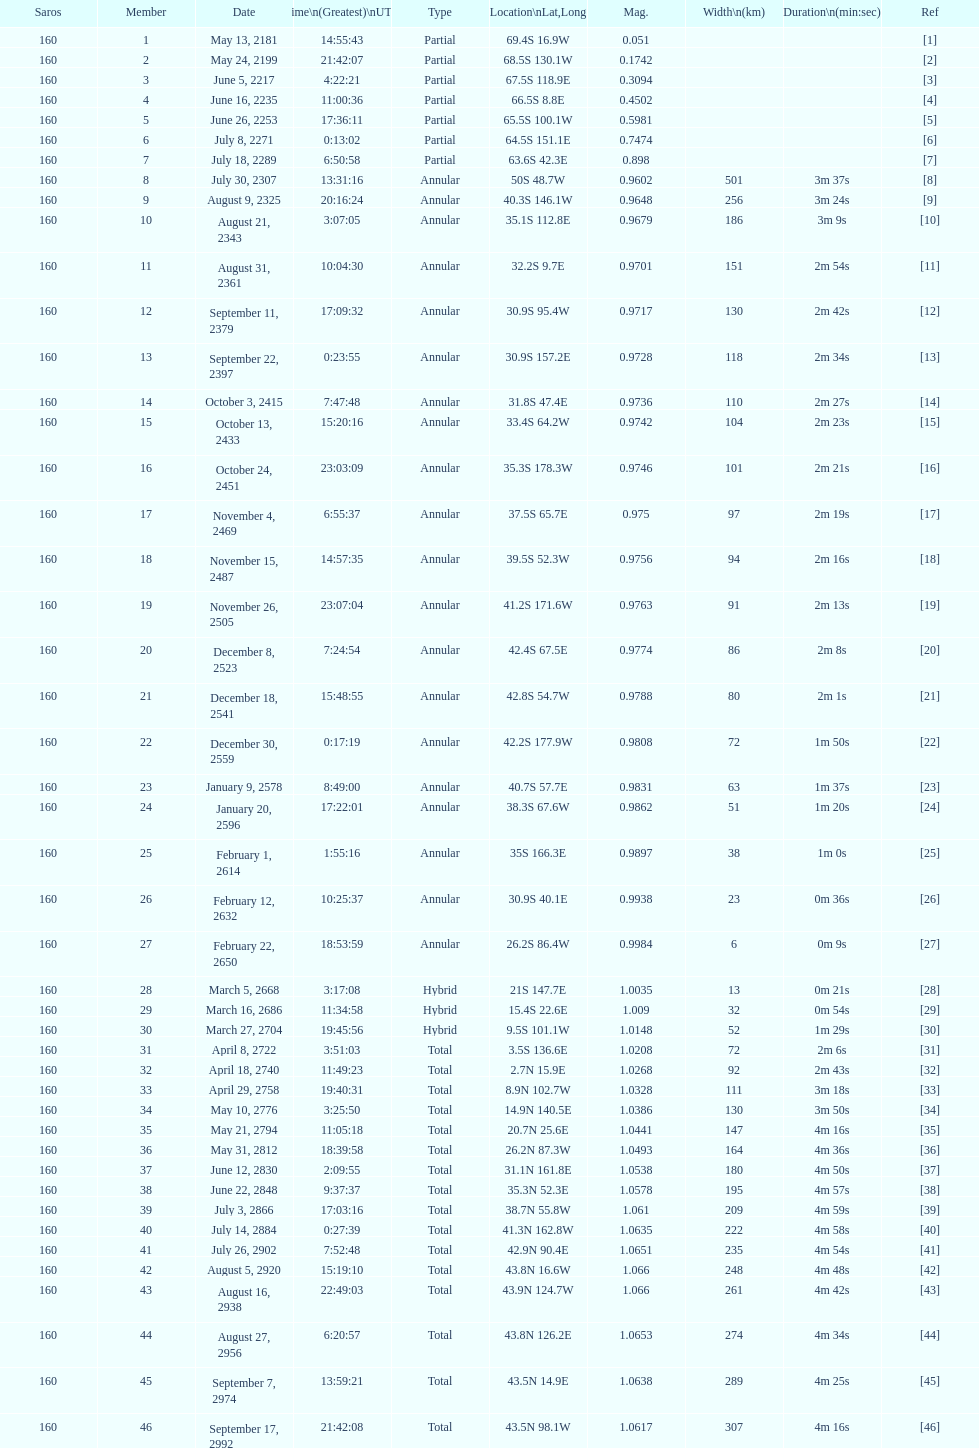How many solar saros events lasted longer than 4 minutes? 12. Could you parse the entire table? {'header': ['Saros', 'Member', 'Date', 'Time\\n(Greatest)\\nUTC', 'Type', 'Location\\nLat,Long', 'Mag.', 'Width\\n(km)', 'Duration\\n(min:sec)', 'Ref'], 'rows': [['160', '1', 'May 13, 2181', '14:55:43', 'Partial', '69.4S 16.9W', '0.051', '', '', '[1]'], ['160', '2', 'May 24, 2199', '21:42:07', 'Partial', '68.5S 130.1W', '0.1742', '', '', '[2]'], ['160', '3', 'June 5, 2217', '4:22:21', 'Partial', '67.5S 118.9E', '0.3094', '', '', '[3]'], ['160', '4', 'June 16, 2235', '11:00:36', 'Partial', '66.5S 8.8E', '0.4502', '', '', '[4]'], ['160', '5', 'June 26, 2253', '17:36:11', 'Partial', '65.5S 100.1W', '0.5981', '', '', '[5]'], ['160', '6', 'July 8, 2271', '0:13:02', 'Partial', '64.5S 151.1E', '0.7474', '', '', '[6]'], ['160', '7', 'July 18, 2289', '6:50:58', 'Partial', '63.6S 42.3E', '0.898', '', '', '[7]'], ['160', '8', 'July 30, 2307', '13:31:16', 'Annular', '50S 48.7W', '0.9602', '501', '3m 37s', '[8]'], ['160', '9', 'August 9, 2325', '20:16:24', 'Annular', '40.3S 146.1W', '0.9648', '256', '3m 24s', '[9]'], ['160', '10', 'August 21, 2343', '3:07:05', 'Annular', '35.1S 112.8E', '0.9679', '186', '3m 9s', '[10]'], ['160', '11', 'August 31, 2361', '10:04:30', 'Annular', '32.2S 9.7E', '0.9701', '151', '2m 54s', '[11]'], ['160', '12', 'September 11, 2379', '17:09:32', 'Annular', '30.9S 95.4W', '0.9717', '130', '2m 42s', '[12]'], ['160', '13', 'September 22, 2397', '0:23:55', 'Annular', '30.9S 157.2E', '0.9728', '118', '2m 34s', '[13]'], ['160', '14', 'October 3, 2415', '7:47:48', 'Annular', '31.8S 47.4E', '0.9736', '110', '2m 27s', '[14]'], ['160', '15', 'October 13, 2433', '15:20:16', 'Annular', '33.4S 64.2W', '0.9742', '104', '2m 23s', '[15]'], ['160', '16', 'October 24, 2451', '23:03:09', 'Annular', '35.3S 178.3W', '0.9746', '101', '2m 21s', '[16]'], ['160', '17', 'November 4, 2469', '6:55:37', 'Annular', '37.5S 65.7E', '0.975', '97', '2m 19s', '[17]'], ['160', '18', 'November 15, 2487', '14:57:35', 'Annular', '39.5S 52.3W', '0.9756', '94', '2m 16s', '[18]'], ['160', '19', 'November 26, 2505', '23:07:04', 'Annular', '41.2S 171.6W', '0.9763', '91', '2m 13s', '[19]'], ['160', '20', 'December 8, 2523', '7:24:54', 'Annular', '42.4S 67.5E', '0.9774', '86', '2m 8s', '[20]'], ['160', '21', 'December 18, 2541', '15:48:55', 'Annular', '42.8S 54.7W', '0.9788', '80', '2m 1s', '[21]'], ['160', '22', 'December 30, 2559', '0:17:19', 'Annular', '42.2S 177.9W', '0.9808', '72', '1m 50s', '[22]'], ['160', '23', 'January 9, 2578', '8:49:00', 'Annular', '40.7S 57.7E', '0.9831', '63', '1m 37s', '[23]'], ['160', '24', 'January 20, 2596', '17:22:01', 'Annular', '38.3S 67.6W', '0.9862', '51', '1m 20s', '[24]'], ['160', '25', 'February 1, 2614', '1:55:16', 'Annular', '35S 166.3E', '0.9897', '38', '1m 0s', '[25]'], ['160', '26', 'February 12, 2632', '10:25:37', 'Annular', '30.9S 40.1E', '0.9938', '23', '0m 36s', '[26]'], ['160', '27', 'February 22, 2650', '18:53:59', 'Annular', '26.2S 86.4W', '0.9984', '6', '0m 9s', '[27]'], ['160', '28', 'March 5, 2668', '3:17:08', 'Hybrid', '21S 147.7E', '1.0035', '13', '0m 21s', '[28]'], ['160', '29', 'March 16, 2686', '11:34:58', 'Hybrid', '15.4S 22.6E', '1.009', '32', '0m 54s', '[29]'], ['160', '30', 'March 27, 2704', '19:45:56', 'Hybrid', '9.5S 101.1W', '1.0148', '52', '1m 29s', '[30]'], ['160', '31', 'April 8, 2722', '3:51:03', 'Total', '3.5S 136.6E', '1.0208', '72', '2m 6s', '[31]'], ['160', '32', 'April 18, 2740', '11:49:23', 'Total', '2.7N 15.9E', '1.0268', '92', '2m 43s', '[32]'], ['160', '33', 'April 29, 2758', '19:40:31', 'Total', '8.9N 102.7W', '1.0328', '111', '3m 18s', '[33]'], ['160', '34', 'May 10, 2776', '3:25:50', 'Total', '14.9N 140.5E', '1.0386', '130', '3m 50s', '[34]'], ['160', '35', 'May 21, 2794', '11:05:18', 'Total', '20.7N 25.6E', '1.0441', '147', '4m 16s', '[35]'], ['160', '36', 'May 31, 2812', '18:39:58', 'Total', '26.2N 87.3W', '1.0493', '164', '4m 36s', '[36]'], ['160', '37', 'June 12, 2830', '2:09:55', 'Total', '31.1N 161.8E', '1.0538', '180', '4m 50s', '[37]'], ['160', '38', 'June 22, 2848', '9:37:37', 'Total', '35.3N 52.3E', '1.0578', '195', '4m 57s', '[38]'], ['160', '39', 'July 3, 2866', '17:03:16', 'Total', '38.7N 55.8W', '1.061', '209', '4m 59s', '[39]'], ['160', '40', 'July 14, 2884', '0:27:39', 'Total', '41.3N 162.8W', '1.0635', '222', '4m 58s', '[40]'], ['160', '41', 'July 26, 2902', '7:52:48', 'Total', '42.9N 90.4E', '1.0651', '235', '4m 54s', '[41]'], ['160', '42', 'August 5, 2920', '15:19:10', 'Total', '43.8N 16.6W', '1.066', '248', '4m 48s', '[42]'], ['160', '43', 'August 16, 2938', '22:49:03', 'Total', '43.9N 124.7W', '1.066', '261', '4m 42s', '[43]'], ['160', '44', 'August 27, 2956', '6:20:57', 'Total', '43.8N 126.2E', '1.0653', '274', '4m 34s', '[44]'], ['160', '45', 'September 7, 2974', '13:59:21', 'Total', '43.5N 14.9E', '1.0638', '289', '4m 25s', '[45]'], ['160', '46', 'September 17, 2992', '21:42:08', 'Total', '43.5N 98.1W', '1.0617', '307', '4m 16s', '[46]']]} 